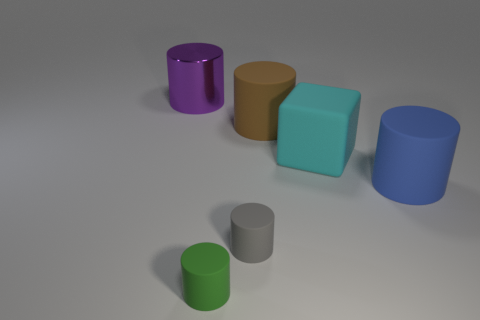Subtract all big brown cylinders. How many cylinders are left? 4 Add 2 big blue rubber things. How many objects exist? 8 Subtract 1 cubes. How many cubes are left? 0 Subtract all blue cylinders. How many cylinders are left? 4 Subtract all blocks. How many objects are left? 5 Subtract all brown cylinders. Subtract all yellow cubes. How many cylinders are left? 4 Subtract all brown rubber objects. Subtract all small gray metal balls. How many objects are left? 5 Add 4 matte cubes. How many matte cubes are left? 5 Add 3 big brown rubber objects. How many big brown rubber objects exist? 4 Subtract 0 yellow balls. How many objects are left? 6 